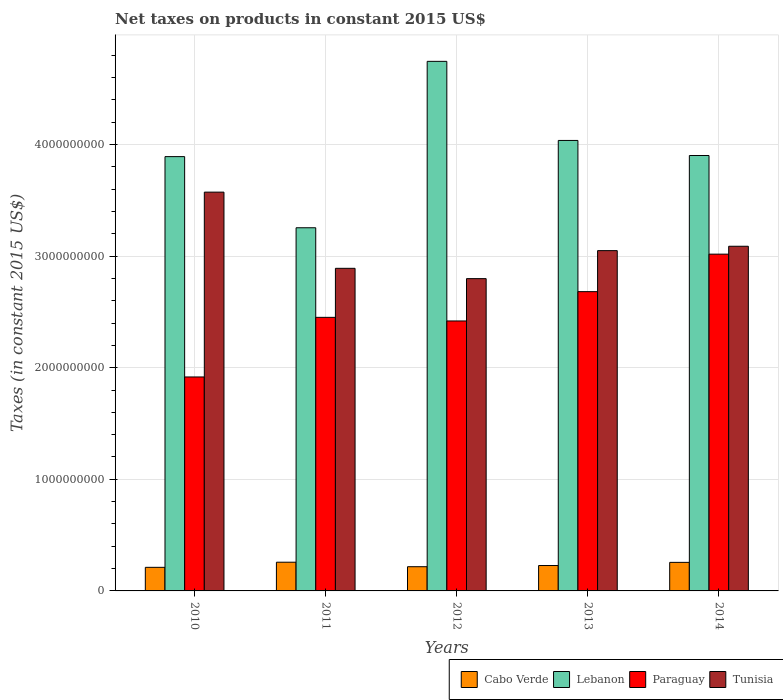How many groups of bars are there?
Your answer should be compact. 5. Are the number of bars per tick equal to the number of legend labels?
Your answer should be very brief. Yes. Are the number of bars on each tick of the X-axis equal?
Your response must be concise. Yes. How many bars are there on the 4th tick from the left?
Give a very brief answer. 4. How many bars are there on the 4th tick from the right?
Provide a succinct answer. 4. What is the net taxes on products in Cabo Verde in 2012?
Provide a succinct answer. 2.17e+08. Across all years, what is the maximum net taxes on products in Tunisia?
Your response must be concise. 3.57e+09. Across all years, what is the minimum net taxes on products in Lebanon?
Your response must be concise. 3.25e+09. In which year was the net taxes on products in Cabo Verde maximum?
Give a very brief answer. 2011. What is the total net taxes on products in Lebanon in the graph?
Ensure brevity in your answer.  1.98e+1. What is the difference between the net taxes on products in Paraguay in 2011 and that in 2012?
Provide a succinct answer. 3.23e+07. What is the difference between the net taxes on products in Paraguay in 2012 and the net taxes on products in Lebanon in 2013?
Offer a very short reply. -1.62e+09. What is the average net taxes on products in Cabo Verde per year?
Make the answer very short. 2.34e+08. In the year 2010, what is the difference between the net taxes on products in Paraguay and net taxes on products in Tunisia?
Give a very brief answer. -1.66e+09. In how many years, is the net taxes on products in Paraguay greater than 1000000000 US$?
Provide a short and direct response. 5. What is the ratio of the net taxes on products in Lebanon in 2012 to that in 2014?
Your response must be concise. 1.22. Is the difference between the net taxes on products in Paraguay in 2010 and 2013 greater than the difference between the net taxes on products in Tunisia in 2010 and 2013?
Your response must be concise. No. What is the difference between the highest and the second highest net taxes on products in Tunisia?
Give a very brief answer. 4.85e+08. What is the difference between the highest and the lowest net taxes on products in Tunisia?
Provide a succinct answer. 7.75e+08. Is the sum of the net taxes on products in Cabo Verde in 2012 and 2013 greater than the maximum net taxes on products in Lebanon across all years?
Offer a very short reply. No. Is it the case that in every year, the sum of the net taxes on products in Cabo Verde and net taxes on products in Tunisia is greater than the sum of net taxes on products in Lebanon and net taxes on products in Paraguay?
Your answer should be compact. No. What does the 1st bar from the left in 2011 represents?
Your response must be concise. Cabo Verde. What does the 1st bar from the right in 2013 represents?
Your answer should be very brief. Tunisia. What is the difference between two consecutive major ticks on the Y-axis?
Give a very brief answer. 1.00e+09. Does the graph contain grids?
Offer a very short reply. Yes. Where does the legend appear in the graph?
Give a very brief answer. Bottom right. How are the legend labels stacked?
Your response must be concise. Horizontal. What is the title of the graph?
Offer a terse response. Net taxes on products in constant 2015 US$. Does "East Asia (all income levels)" appear as one of the legend labels in the graph?
Give a very brief answer. No. What is the label or title of the X-axis?
Ensure brevity in your answer.  Years. What is the label or title of the Y-axis?
Your response must be concise. Taxes (in constant 2015 US$). What is the Taxes (in constant 2015 US$) in Cabo Verde in 2010?
Offer a very short reply. 2.11e+08. What is the Taxes (in constant 2015 US$) of Lebanon in 2010?
Your response must be concise. 3.89e+09. What is the Taxes (in constant 2015 US$) in Paraguay in 2010?
Offer a very short reply. 1.92e+09. What is the Taxes (in constant 2015 US$) in Tunisia in 2010?
Offer a terse response. 3.57e+09. What is the Taxes (in constant 2015 US$) of Cabo Verde in 2011?
Provide a short and direct response. 2.57e+08. What is the Taxes (in constant 2015 US$) of Lebanon in 2011?
Your answer should be very brief. 3.25e+09. What is the Taxes (in constant 2015 US$) of Paraguay in 2011?
Offer a terse response. 2.45e+09. What is the Taxes (in constant 2015 US$) of Tunisia in 2011?
Ensure brevity in your answer.  2.89e+09. What is the Taxes (in constant 2015 US$) in Cabo Verde in 2012?
Ensure brevity in your answer.  2.17e+08. What is the Taxes (in constant 2015 US$) of Lebanon in 2012?
Your answer should be compact. 4.74e+09. What is the Taxes (in constant 2015 US$) of Paraguay in 2012?
Offer a terse response. 2.42e+09. What is the Taxes (in constant 2015 US$) of Tunisia in 2012?
Provide a short and direct response. 2.80e+09. What is the Taxes (in constant 2015 US$) in Cabo Verde in 2013?
Provide a succinct answer. 2.28e+08. What is the Taxes (in constant 2015 US$) of Lebanon in 2013?
Provide a short and direct response. 4.04e+09. What is the Taxes (in constant 2015 US$) in Paraguay in 2013?
Provide a short and direct response. 2.68e+09. What is the Taxes (in constant 2015 US$) of Tunisia in 2013?
Provide a short and direct response. 3.05e+09. What is the Taxes (in constant 2015 US$) in Cabo Verde in 2014?
Offer a terse response. 2.56e+08. What is the Taxes (in constant 2015 US$) of Lebanon in 2014?
Make the answer very short. 3.90e+09. What is the Taxes (in constant 2015 US$) of Paraguay in 2014?
Provide a succinct answer. 3.02e+09. What is the Taxes (in constant 2015 US$) in Tunisia in 2014?
Make the answer very short. 3.09e+09. Across all years, what is the maximum Taxes (in constant 2015 US$) of Cabo Verde?
Your response must be concise. 2.57e+08. Across all years, what is the maximum Taxes (in constant 2015 US$) of Lebanon?
Your answer should be compact. 4.74e+09. Across all years, what is the maximum Taxes (in constant 2015 US$) of Paraguay?
Make the answer very short. 3.02e+09. Across all years, what is the maximum Taxes (in constant 2015 US$) of Tunisia?
Ensure brevity in your answer.  3.57e+09. Across all years, what is the minimum Taxes (in constant 2015 US$) of Cabo Verde?
Ensure brevity in your answer.  2.11e+08. Across all years, what is the minimum Taxes (in constant 2015 US$) in Lebanon?
Keep it short and to the point. 3.25e+09. Across all years, what is the minimum Taxes (in constant 2015 US$) of Paraguay?
Offer a terse response. 1.92e+09. Across all years, what is the minimum Taxes (in constant 2015 US$) of Tunisia?
Ensure brevity in your answer.  2.80e+09. What is the total Taxes (in constant 2015 US$) of Cabo Verde in the graph?
Give a very brief answer. 1.17e+09. What is the total Taxes (in constant 2015 US$) of Lebanon in the graph?
Keep it short and to the point. 1.98e+1. What is the total Taxes (in constant 2015 US$) of Paraguay in the graph?
Offer a very short reply. 1.25e+1. What is the total Taxes (in constant 2015 US$) of Tunisia in the graph?
Make the answer very short. 1.54e+1. What is the difference between the Taxes (in constant 2015 US$) in Cabo Verde in 2010 and that in 2011?
Give a very brief answer. -4.58e+07. What is the difference between the Taxes (in constant 2015 US$) in Lebanon in 2010 and that in 2011?
Your response must be concise. 6.37e+08. What is the difference between the Taxes (in constant 2015 US$) of Paraguay in 2010 and that in 2011?
Make the answer very short. -5.34e+08. What is the difference between the Taxes (in constant 2015 US$) of Tunisia in 2010 and that in 2011?
Offer a very short reply. 6.83e+08. What is the difference between the Taxes (in constant 2015 US$) in Cabo Verde in 2010 and that in 2012?
Your answer should be compact. -5.61e+06. What is the difference between the Taxes (in constant 2015 US$) of Lebanon in 2010 and that in 2012?
Keep it short and to the point. -8.53e+08. What is the difference between the Taxes (in constant 2015 US$) in Paraguay in 2010 and that in 2012?
Your answer should be compact. -5.02e+08. What is the difference between the Taxes (in constant 2015 US$) in Tunisia in 2010 and that in 2012?
Offer a very short reply. 7.75e+08. What is the difference between the Taxes (in constant 2015 US$) in Cabo Verde in 2010 and that in 2013?
Your answer should be compact. -1.62e+07. What is the difference between the Taxes (in constant 2015 US$) of Lebanon in 2010 and that in 2013?
Give a very brief answer. -1.45e+08. What is the difference between the Taxes (in constant 2015 US$) of Paraguay in 2010 and that in 2013?
Give a very brief answer. -7.64e+08. What is the difference between the Taxes (in constant 2015 US$) in Tunisia in 2010 and that in 2013?
Give a very brief answer. 5.24e+08. What is the difference between the Taxes (in constant 2015 US$) of Cabo Verde in 2010 and that in 2014?
Keep it short and to the point. -4.44e+07. What is the difference between the Taxes (in constant 2015 US$) in Lebanon in 2010 and that in 2014?
Offer a terse response. -9.84e+06. What is the difference between the Taxes (in constant 2015 US$) of Paraguay in 2010 and that in 2014?
Ensure brevity in your answer.  -1.10e+09. What is the difference between the Taxes (in constant 2015 US$) of Tunisia in 2010 and that in 2014?
Offer a very short reply. 4.85e+08. What is the difference between the Taxes (in constant 2015 US$) of Cabo Verde in 2011 and that in 2012?
Ensure brevity in your answer.  4.02e+07. What is the difference between the Taxes (in constant 2015 US$) of Lebanon in 2011 and that in 2012?
Your answer should be very brief. -1.49e+09. What is the difference between the Taxes (in constant 2015 US$) of Paraguay in 2011 and that in 2012?
Your response must be concise. 3.23e+07. What is the difference between the Taxes (in constant 2015 US$) in Tunisia in 2011 and that in 2012?
Ensure brevity in your answer.  9.24e+07. What is the difference between the Taxes (in constant 2015 US$) of Cabo Verde in 2011 and that in 2013?
Your response must be concise. 2.96e+07. What is the difference between the Taxes (in constant 2015 US$) in Lebanon in 2011 and that in 2013?
Your answer should be very brief. -7.82e+08. What is the difference between the Taxes (in constant 2015 US$) in Paraguay in 2011 and that in 2013?
Your answer should be very brief. -2.30e+08. What is the difference between the Taxes (in constant 2015 US$) in Tunisia in 2011 and that in 2013?
Ensure brevity in your answer.  -1.58e+08. What is the difference between the Taxes (in constant 2015 US$) in Cabo Verde in 2011 and that in 2014?
Make the answer very short. 1.39e+06. What is the difference between the Taxes (in constant 2015 US$) in Lebanon in 2011 and that in 2014?
Provide a succinct answer. -6.47e+08. What is the difference between the Taxes (in constant 2015 US$) in Paraguay in 2011 and that in 2014?
Your answer should be very brief. -5.66e+08. What is the difference between the Taxes (in constant 2015 US$) in Tunisia in 2011 and that in 2014?
Your answer should be very brief. -1.98e+08. What is the difference between the Taxes (in constant 2015 US$) in Cabo Verde in 2012 and that in 2013?
Provide a short and direct response. -1.06e+07. What is the difference between the Taxes (in constant 2015 US$) of Lebanon in 2012 and that in 2013?
Ensure brevity in your answer.  7.09e+08. What is the difference between the Taxes (in constant 2015 US$) of Paraguay in 2012 and that in 2013?
Your response must be concise. -2.63e+08. What is the difference between the Taxes (in constant 2015 US$) in Tunisia in 2012 and that in 2013?
Provide a succinct answer. -2.51e+08. What is the difference between the Taxes (in constant 2015 US$) in Cabo Verde in 2012 and that in 2014?
Offer a very short reply. -3.88e+07. What is the difference between the Taxes (in constant 2015 US$) of Lebanon in 2012 and that in 2014?
Provide a succinct answer. 8.44e+08. What is the difference between the Taxes (in constant 2015 US$) in Paraguay in 2012 and that in 2014?
Ensure brevity in your answer.  -5.99e+08. What is the difference between the Taxes (in constant 2015 US$) of Tunisia in 2012 and that in 2014?
Provide a short and direct response. -2.90e+08. What is the difference between the Taxes (in constant 2015 US$) in Cabo Verde in 2013 and that in 2014?
Your response must be concise. -2.82e+07. What is the difference between the Taxes (in constant 2015 US$) of Lebanon in 2013 and that in 2014?
Provide a succinct answer. 1.35e+08. What is the difference between the Taxes (in constant 2015 US$) in Paraguay in 2013 and that in 2014?
Your response must be concise. -3.36e+08. What is the difference between the Taxes (in constant 2015 US$) in Tunisia in 2013 and that in 2014?
Keep it short and to the point. -3.92e+07. What is the difference between the Taxes (in constant 2015 US$) of Cabo Verde in 2010 and the Taxes (in constant 2015 US$) of Lebanon in 2011?
Keep it short and to the point. -3.04e+09. What is the difference between the Taxes (in constant 2015 US$) in Cabo Verde in 2010 and the Taxes (in constant 2015 US$) in Paraguay in 2011?
Your answer should be very brief. -2.24e+09. What is the difference between the Taxes (in constant 2015 US$) in Cabo Verde in 2010 and the Taxes (in constant 2015 US$) in Tunisia in 2011?
Give a very brief answer. -2.68e+09. What is the difference between the Taxes (in constant 2015 US$) in Lebanon in 2010 and the Taxes (in constant 2015 US$) in Paraguay in 2011?
Offer a very short reply. 1.44e+09. What is the difference between the Taxes (in constant 2015 US$) in Lebanon in 2010 and the Taxes (in constant 2015 US$) in Tunisia in 2011?
Provide a short and direct response. 1.00e+09. What is the difference between the Taxes (in constant 2015 US$) in Paraguay in 2010 and the Taxes (in constant 2015 US$) in Tunisia in 2011?
Ensure brevity in your answer.  -9.73e+08. What is the difference between the Taxes (in constant 2015 US$) of Cabo Verde in 2010 and the Taxes (in constant 2015 US$) of Lebanon in 2012?
Make the answer very short. -4.53e+09. What is the difference between the Taxes (in constant 2015 US$) in Cabo Verde in 2010 and the Taxes (in constant 2015 US$) in Paraguay in 2012?
Your response must be concise. -2.21e+09. What is the difference between the Taxes (in constant 2015 US$) of Cabo Verde in 2010 and the Taxes (in constant 2015 US$) of Tunisia in 2012?
Your answer should be very brief. -2.59e+09. What is the difference between the Taxes (in constant 2015 US$) of Lebanon in 2010 and the Taxes (in constant 2015 US$) of Paraguay in 2012?
Give a very brief answer. 1.47e+09. What is the difference between the Taxes (in constant 2015 US$) in Lebanon in 2010 and the Taxes (in constant 2015 US$) in Tunisia in 2012?
Your answer should be compact. 1.09e+09. What is the difference between the Taxes (in constant 2015 US$) of Paraguay in 2010 and the Taxes (in constant 2015 US$) of Tunisia in 2012?
Provide a succinct answer. -8.81e+08. What is the difference between the Taxes (in constant 2015 US$) of Cabo Verde in 2010 and the Taxes (in constant 2015 US$) of Lebanon in 2013?
Provide a succinct answer. -3.82e+09. What is the difference between the Taxes (in constant 2015 US$) of Cabo Verde in 2010 and the Taxes (in constant 2015 US$) of Paraguay in 2013?
Offer a terse response. -2.47e+09. What is the difference between the Taxes (in constant 2015 US$) of Cabo Verde in 2010 and the Taxes (in constant 2015 US$) of Tunisia in 2013?
Make the answer very short. -2.84e+09. What is the difference between the Taxes (in constant 2015 US$) of Lebanon in 2010 and the Taxes (in constant 2015 US$) of Paraguay in 2013?
Give a very brief answer. 1.21e+09. What is the difference between the Taxes (in constant 2015 US$) in Lebanon in 2010 and the Taxes (in constant 2015 US$) in Tunisia in 2013?
Your answer should be compact. 8.42e+08. What is the difference between the Taxes (in constant 2015 US$) in Paraguay in 2010 and the Taxes (in constant 2015 US$) in Tunisia in 2013?
Your response must be concise. -1.13e+09. What is the difference between the Taxes (in constant 2015 US$) of Cabo Verde in 2010 and the Taxes (in constant 2015 US$) of Lebanon in 2014?
Give a very brief answer. -3.69e+09. What is the difference between the Taxes (in constant 2015 US$) of Cabo Verde in 2010 and the Taxes (in constant 2015 US$) of Paraguay in 2014?
Ensure brevity in your answer.  -2.81e+09. What is the difference between the Taxes (in constant 2015 US$) in Cabo Verde in 2010 and the Taxes (in constant 2015 US$) in Tunisia in 2014?
Offer a terse response. -2.88e+09. What is the difference between the Taxes (in constant 2015 US$) of Lebanon in 2010 and the Taxes (in constant 2015 US$) of Paraguay in 2014?
Offer a terse response. 8.74e+08. What is the difference between the Taxes (in constant 2015 US$) of Lebanon in 2010 and the Taxes (in constant 2015 US$) of Tunisia in 2014?
Make the answer very short. 8.03e+08. What is the difference between the Taxes (in constant 2015 US$) in Paraguay in 2010 and the Taxes (in constant 2015 US$) in Tunisia in 2014?
Your answer should be compact. -1.17e+09. What is the difference between the Taxes (in constant 2015 US$) in Cabo Verde in 2011 and the Taxes (in constant 2015 US$) in Lebanon in 2012?
Your answer should be compact. -4.49e+09. What is the difference between the Taxes (in constant 2015 US$) in Cabo Verde in 2011 and the Taxes (in constant 2015 US$) in Paraguay in 2012?
Your response must be concise. -2.16e+09. What is the difference between the Taxes (in constant 2015 US$) of Cabo Verde in 2011 and the Taxes (in constant 2015 US$) of Tunisia in 2012?
Ensure brevity in your answer.  -2.54e+09. What is the difference between the Taxes (in constant 2015 US$) of Lebanon in 2011 and the Taxes (in constant 2015 US$) of Paraguay in 2012?
Your answer should be compact. 8.35e+08. What is the difference between the Taxes (in constant 2015 US$) of Lebanon in 2011 and the Taxes (in constant 2015 US$) of Tunisia in 2012?
Your answer should be very brief. 4.56e+08. What is the difference between the Taxes (in constant 2015 US$) in Paraguay in 2011 and the Taxes (in constant 2015 US$) in Tunisia in 2012?
Keep it short and to the point. -3.47e+08. What is the difference between the Taxes (in constant 2015 US$) in Cabo Verde in 2011 and the Taxes (in constant 2015 US$) in Lebanon in 2013?
Offer a very short reply. -3.78e+09. What is the difference between the Taxes (in constant 2015 US$) in Cabo Verde in 2011 and the Taxes (in constant 2015 US$) in Paraguay in 2013?
Provide a succinct answer. -2.42e+09. What is the difference between the Taxes (in constant 2015 US$) of Cabo Verde in 2011 and the Taxes (in constant 2015 US$) of Tunisia in 2013?
Your answer should be very brief. -2.79e+09. What is the difference between the Taxes (in constant 2015 US$) of Lebanon in 2011 and the Taxes (in constant 2015 US$) of Paraguay in 2013?
Offer a terse response. 5.72e+08. What is the difference between the Taxes (in constant 2015 US$) in Lebanon in 2011 and the Taxes (in constant 2015 US$) in Tunisia in 2013?
Keep it short and to the point. 2.05e+08. What is the difference between the Taxes (in constant 2015 US$) in Paraguay in 2011 and the Taxes (in constant 2015 US$) in Tunisia in 2013?
Your response must be concise. -5.98e+08. What is the difference between the Taxes (in constant 2015 US$) of Cabo Verde in 2011 and the Taxes (in constant 2015 US$) of Lebanon in 2014?
Keep it short and to the point. -3.64e+09. What is the difference between the Taxes (in constant 2015 US$) in Cabo Verde in 2011 and the Taxes (in constant 2015 US$) in Paraguay in 2014?
Provide a short and direct response. -2.76e+09. What is the difference between the Taxes (in constant 2015 US$) in Cabo Verde in 2011 and the Taxes (in constant 2015 US$) in Tunisia in 2014?
Keep it short and to the point. -2.83e+09. What is the difference between the Taxes (in constant 2015 US$) of Lebanon in 2011 and the Taxes (in constant 2015 US$) of Paraguay in 2014?
Provide a succinct answer. 2.36e+08. What is the difference between the Taxes (in constant 2015 US$) of Lebanon in 2011 and the Taxes (in constant 2015 US$) of Tunisia in 2014?
Make the answer very short. 1.66e+08. What is the difference between the Taxes (in constant 2015 US$) of Paraguay in 2011 and the Taxes (in constant 2015 US$) of Tunisia in 2014?
Provide a succinct answer. -6.37e+08. What is the difference between the Taxes (in constant 2015 US$) in Cabo Verde in 2012 and the Taxes (in constant 2015 US$) in Lebanon in 2013?
Make the answer very short. -3.82e+09. What is the difference between the Taxes (in constant 2015 US$) of Cabo Verde in 2012 and the Taxes (in constant 2015 US$) of Paraguay in 2013?
Your answer should be very brief. -2.46e+09. What is the difference between the Taxes (in constant 2015 US$) of Cabo Verde in 2012 and the Taxes (in constant 2015 US$) of Tunisia in 2013?
Your answer should be compact. -2.83e+09. What is the difference between the Taxes (in constant 2015 US$) of Lebanon in 2012 and the Taxes (in constant 2015 US$) of Paraguay in 2013?
Give a very brief answer. 2.06e+09. What is the difference between the Taxes (in constant 2015 US$) of Lebanon in 2012 and the Taxes (in constant 2015 US$) of Tunisia in 2013?
Give a very brief answer. 1.70e+09. What is the difference between the Taxes (in constant 2015 US$) of Paraguay in 2012 and the Taxes (in constant 2015 US$) of Tunisia in 2013?
Your response must be concise. -6.30e+08. What is the difference between the Taxes (in constant 2015 US$) in Cabo Verde in 2012 and the Taxes (in constant 2015 US$) in Lebanon in 2014?
Offer a very short reply. -3.68e+09. What is the difference between the Taxes (in constant 2015 US$) in Cabo Verde in 2012 and the Taxes (in constant 2015 US$) in Paraguay in 2014?
Give a very brief answer. -2.80e+09. What is the difference between the Taxes (in constant 2015 US$) in Cabo Verde in 2012 and the Taxes (in constant 2015 US$) in Tunisia in 2014?
Your answer should be very brief. -2.87e+09. What is the difference between the Taxes (in constant 2015 US$) of Lebanon in 2012 and the Taxes (in constant 2015 US$) of Paraguay in 2014?
Your response must be concise. 1.73e+09. What is the difference between the Taxes (in constant 2015 US$) in Lebanon in 2012 and the Taxes (in constant 2015 US$) in Tunisia in 2014?
Make the answer very short. 1.66e+09. What is the difference between the Taxes (in constant 2015 US$) in Paraguay in 2012 and the Taxes (in constant 2015 US$) in Tunisia in 2014?
Give a very brief answer. -6.69e+08. What is the difference between the Taxes (in constant 2015 US$) of Cabo Verde in 2013 and the Taxes (in constant 2015 US$) of Lebanon in 2014?
Provide a succinct answer. -3.67e+09. What is the difference between the Taxes (in constant 2015 US$) of Cabo Verde in 2013 and the Taxes (in constant 2015 US$) of Paraguay in 2014?
Offer a terse response. -2.79e+09. What is the difference between the Taxes (in constant 2015 US$) in Cabo Verde in 2013 and the Taxes (in constant 2015 US$) in Tunisia in 2014?
Give a very brief answer. -2.86e+09. What is the difference between the Taxes (in constant 2015 US$) in Lebanon in 2013 and the Taxes (in constant 2015 US$) in Paraguay in 2014?
Provide a succinct answer. 1.02e+09. What is the difference between the Taxes (in constant 2015 US$) of Lebanon in 2013 and the Taxes (in constant 2015 US$) of Tunisia in 2014?
Your answer should be very brief. 9.48e+08. What is the difference between the Taxes (in constant 2015 US$) of Paraguay in 2013 and the Taxes (in constant 2015 US$) of Tunisia in 2014?
Keep it short and to the point. -4.07e+08. What is the average Taxes (in constant 2015 US$) of Cabo Verde per year?
Your answer should be very brief. 2.34e+08. What is the average Taxes (in constant 2015 US$) of Lebanon per year?
Make the answer very short. 3.97e+09. What is the average Taxes (in constant 2015 US$) of Paraguay per year?
Make the answer very short. 2.50e+09. What is the average Taxes (in constant 2015 US$) of Tunisia per year?
Provide a succinct answer. 3.08e+09. In the year 2010, what is the difference between the Taxes (in constant 2015 US$) in Cabo Verde and Taxes (in constant 2015 US$) in Lebanon?
Provide a succinct answer. -3.68e+09. In the year 2010, what is the difference between the Taxes (in constant 2015 US$) of Cabo Verde and Taxes (in constant 2015 US$) of Paraguay?
Make the answer very short. -1.71e+09. In the year 2010, what is the difference between the Taxes (in constant 2015 US$) of Cabo Verde and Taxes (in constant 2015 US$) of Tunisia?
Provide a succinct answer. -3.36e+09. In the year 2010, what is the difference between the Taxes (in constant 2015 US$) in Lebanon and Taxes (in constant 2015 US$) in Paraguay?
Provide a succinct answer. 1.97e+09. In the year 2010, what is the difference between the Taxes (in constant 2015 US$) in Lebanon and Taxes (in constant 2015 US$) in Tunisia?
Make the answer very short. 3.18e+08. In the year 2010, what is the difference between the Taxes (in constant 2015 US$) in Paraguay and Taxes (in constant 2015 US$) in Tunisia?
Your answer should be compact. -1.66e+09. In the year 2011, what is the difference between the Taxes (in constant 2015 US$) of Cabo Verde and Taxes (in constant 2015 US$) of Lebanon?
Your answer should be very brief. -3.00e+09. In the year 2011, what is the difference between the Taxes (in constant 2015 US$) in Cabo Verde and Taxes (in constant 2015 US$) in Paraguay?
Offer a terse response. -2.19e+09. In the year 2011, what is the difference between the Taxes (in constant 2015 US$) in Cabo Verde and Taxes (in constant 2015 US$) in Tunisia?
Provide a short and direct response. -2.63e+09. In the year 2011, what is the difference between the Taxes (in constant 2015 US$) in Lebanon and Taxes (in constant 2015 US$) in Paraguay?
Give a very brief answer. 8.03e+08. In the year 2011, what is the difference between the Taxes (in constant 2015 US$) of Lebanon and Taxes (in constant 2015 US$) of Tunisia?
Your response must be concise. 3.63e+08. In the year 2011, what is the difference between the Taxes (in constant 2015 US$) of Paraguay and Taxes (in constant 2015 US$) of Tunisia?
Provide a succinct answer. -4.39e+08. In the year 2012, what is the difference between the Taxes (in constant 2015 US$) of Cabo Verde and Taxes (in constant 2015 US$) of Lebanon?
Provide a succinct answer. -4.53e+09. In the year 2012, what is the difference between the Taxes (in constant 2015 US$) in Cabo Verde and Taxes (in constant 2015 US$) in Paraguay?
Offer a terse response. -2.20e+09. In the year 2012, what is the difference between the Taxes (in constant 2015 US$) in Cabo Verde and Taxes (in constant 2015 US$) in Tunisia?
Provide a succinct answer. -2.58e+09. In the year 2012, what is the difference between the Taxes (in constant 2015 US$) of Lebanon and Taxes (in constant 2015 US$) of Paraguay?
Your answer should be compact. 2.33e+09. In the year 2012, what is the difference between the Taxes (in constant 2015 US$) of Lebanon and Taxes (in constant 2015 US$) of Tunisia?
Offer a terse response. 1.95e+09. In the year 2012, what is the difference between the Taxes (in constant 2015 US$) of Paraguay and Taxes (in constant 2015 US$) of Tunisia?
Your response must be concise. -3.79e+08. In the year 2013, what is the difference between the Taxes (in constant 2015 US$) of Cabo Verde and Taxes (in constant 2015 US$) of Lebanon?
Your answer should be compact. -3.81e+09. In the year 2013, what is the difference between the Taxes (in constant 2015 US$) in Cabo Verde and Taxes (in constant 2015 US$) in Paraguay?
Give a very brief answer. -2.45e+09. In the year 2013, what is the difference between the Taxes (in constant 2015 US$) of Cabo Verde and Taxes (in constant 2015 US$) of Tunisia?
Provide a short and direct response. -2.82e+09. In the year 2013, what is the difference between the Taxes (in constant 2015 US$) of Lebanon and Taxes (in constant 2015 US$) of Paraguay?
Offer a terse response. 1.35e+09. In the year 2013, what is the difference between the Taxes (in constant 2015 US$) in Lebanon and Taxes (in constant 2015 US$) in Tunisia?
Provide a short and direct response. 9.87e+08. In the year 2013, what is the difference between the Taxes (in constant 2015 US$) in Paraguay and Taxes (in constant 2015 US$) in Tunisia?
Your answer should be compact. -3.67e+08. In the year 2014, what is the difference between the Taxes (in constant 2015 US$) in Cabo Verde and Taxes (in constant 2015 US$) in Lebanon?
Make the answer very short. -3.65e+09. In the year 2014, what is the difference between the Taxes (in constant 2015 US$) of Cabo Verde and Taxes (in constant 2015 US$) of Paraguay?
Offer a terse response. -2.76e+09. In the year 2014, what is the difference between the Taxes (in constant 2015 US$) in Cabo Verde and Taxes (in constant 2015 US$) in Tunisia?
Your answer should be very brief. -2.83e+09. In the year 2014, what is the difference between the Taxes (in constant 2015 US$) in Lebanon and Taxes (in constant 2015 US$) in Paraguay?
Provide a succinct answer. 8.84e+08. In the year 2014, what is the difference between the Taxes (in constant 2015 US$) of Lebanon and Taxes (in constant 2015 US$) of Tunisia?
Provide a succinct answer. 8.13e+08. In the year 2014, what is the difference between the Taxes (in constant 2015 US$) of Paraguay and Taxes (in constant 2015 US$) of Tunisia?
Provide a short and direct response. -7.07e+07. What is the ratio of the Taxes (in constant 2015 US$) of Cabo Verde in 2010 to that in 2011?
Give a very brief answer. 0.82. What is the ratio of the Taxes (in constant 2015 US$) of Lebanon in 2010 to that in 2011?
Ensure brevity in your answer.  1.2. What is the ratio of the Taxes (in constant 2015 US$) of Paraguay in 2010 to that in 2011?
Your answer should be compact. 0.78. What is the ratio of the Taxes (in constant 2015 US$) of Tunisia in 2010 to that in 2011?
Make the answer very short. 1.24. What is the ratio of the Taxes (in constant 2015 US$) in Cabo Verde in 2010 to that in 2012?
Keep it short and to the point. 0.97. What is the ratio of the Taxes (in constant 2015 US$) of Lebanon in 2010 to that in 2012?
Provide a succinct answer. 0.82. What is the ratio of the Taxes (in constant 2015 US$) of Paraguay in 2010 to that in 2012?
Make the answer very short. 0.79. What is the ratio of the Taxes (in constant 2015 US$) in Tunisia in 2010 to that in 2012?
Your answer should be very brief. 1.28. What is the ratio of the Taxes (in constant 2015 US$) of Cabo Verde in 2010 to that in 2013?
Make the answer very short. 0.93. What is the ratio of the Taxes (in constant 2015 US$) of Lebanon in 2010 to that in 2013?
Your answer should be very brief. 0.96. What is the ratio of the Taxes (in constant 2015 US$) in Paraguay in 2010 to that in 2013?
Make the answer very short. 0.71. What is the ratio of the Taxes (in constant 2015 US$) of Tunisia in 2010 to that in 2013?
Your response must be concise. 1.17. What is the ratio of the Taxes (in constant 2015 US$) in Cabo Verde in 2010 to that in 2014?
Offer a very short reply. 0.83. What is the ratio of the Taxes (in constant 2015 US$) of Lebanon in 2010 to that in 2014?
Keep it short and to the point. 1. What is the ratio of the Taxes (in constant 2015 US$) in Paraguay in 2010 to that in 2014?
Make the answer very short. 0.64. What is the ratio of the Taxes (in constant 2015 US$) in Tunisia in 2010 to that in 2014?
Offer a very short reply. 1.16. What is the ratio of the Taxes (in constant 2015 US$) of Cabo Verde in 2011 to that in 2012?
Your answer should be compact. 1.19. What is the ratio of the Taxes (in constant 2015 US$) in Lebanon in 2011 to that in 2012?
Make the answer very short. 0.69. What is the ratio of the Taxes (in constant 2015 US$) of Paraguay in 2011 to that in 2012?
Keep it short and to the point. 1.01. What is the ratio of the Taxes (in constant 2015 US$) of Tunisia in 2011 to that in 2012?
Ensure brevity in your answer.  1.03. What is the ratio of the Taxes (in constant 2015 US$) of Cabo Verde in 2011 to that in 2013?
Give a very brief answer. 1.13. What is the ratio of the Taxes (in constant 2015 US$) of Lebanon in 2011 to that in 2013?
Ensure brevity in your answer.  0.81. What is the ratio of the Taxes (in constant 2015 US$) in Paraguay in 2011 to that in 2013?
Your response must be concise. 0.91. What is the ratio of the Taxes (in constant 2015 US$) of Tunisia in 2011 to that in 2013?
Provide a succinct answer. 0.95. What is the ratio of the Taxes (in constant 2015 US$) of Cabo Verde in 2011 to that in 2014?
Your answer should be very brief. 1.01. What is the ratio of the Taxes (in constant 2015 US$) in Lebanon in 2011 to that in 2014?
Offer a very short reply. 0.83. What is the ratio of the Taxes (in constant 2015 US$) in Paraguay in 2011 to that in 2014?
Your answer should be compact. 0.81. What is the ratio of the Taxes (in constant 2015 US$) in Tunisia in 2011 to that in 2014?
Keep it short and to the point. 0.94. What is the ratio of the Taxes (in constant 2015 US$) in Cabo Verde in 2012 to that in 2013?
Ensure brevity in your answer.  0.95. What is the ratio of the Taxes (in constant 2015 US$) in Lebanon in 2012 to that in 2013?
Offer a terse response. 1.18. What is the ratio of the Taxes (in constant 2015 US$) of Paraguay in 2012 to that in 2013?
Make the answer very short. 0.9. What is the ratio of the Taxes (in constant 2015 US$) of Tunisia in 2012 to that in 2013?
Provide a short and direct response. 0.92. What is the ratio of the Taxes (in constant 2015 US$) in Cabo Verde in 2012 to that in 2014?
Your answer should be very brief. 0.85. What is the ratio of the Taxes (in constant 2015 US$) in Lebanon in 2012 to that in 2014?
Your answer should be compact. 1.22. What is the ratio of the Taxes (in constant 2015 US$) in Paraguay in 2012 to that in 2014?
Your answer should be compact. 0.8. What is the ratio of the Taxes (in constant 2015 US$) of Tunisia in 2012 to that in 2014?
Your response must be concise. 0.91. What is the ratio of the Taxes (in constant 2015 US$) in Cabo Verde in 2013 to that in 2014?
Provide a succinct answer. 0.89. What is the ratio of the Taxes (in constant 2015 US$) of Lebanon in 2013 to that in 2014?
Your answer should be compact. 1.03. What is the ratio of the Taxes (in constant 2015 US$) of Paraguay in 2013 to that in 2014?
Give a very brief answer. 0.89. What is the ratio of the Taxes (in constant 2015 US$) in Tunisia in 2013 to that in 2014?
Your response must be concise. 0.99. What is the difference between the highest and the second highest Taxes (in constant 2015 US$) of Cabo Verde?
Keep it short and to the point. 1.39e+06. What is the difference between the highest and the second highest Taxes (in constant 2015 US$) of Lebanon?
Offer a terse response. 7.09e+08. What is the difference between the highest and the second highest Taxes (in constant 2015 US$) in Paraguay?
Your answer should be compact. 3.36e+08. What is the difference between the highest and the second highest Taxes (in constant 2015 US$) in Tunisia?
Your answer should be compact. 4.85e+08. What is the difference between the highest and the lowest Taxes (in constant 2015 US$) in Cabo Verde?
Your response must be concise. 4.58e+07. What is the difference between the highest and the lowest Taxes (in constant 2015 US$) in Lebanon?
Offer a very short reply. 1.49e+09. What is the difference between the highest and the lowest Taxes (in constant 2015 US$) of Paraguay?
Provide a succinct answer. 1.10e+09. What is the difference between the highest and the lowest Taxes (in constant 2015 US$) in Tunisia?
Offer a very short reply. 7.75e+08. 